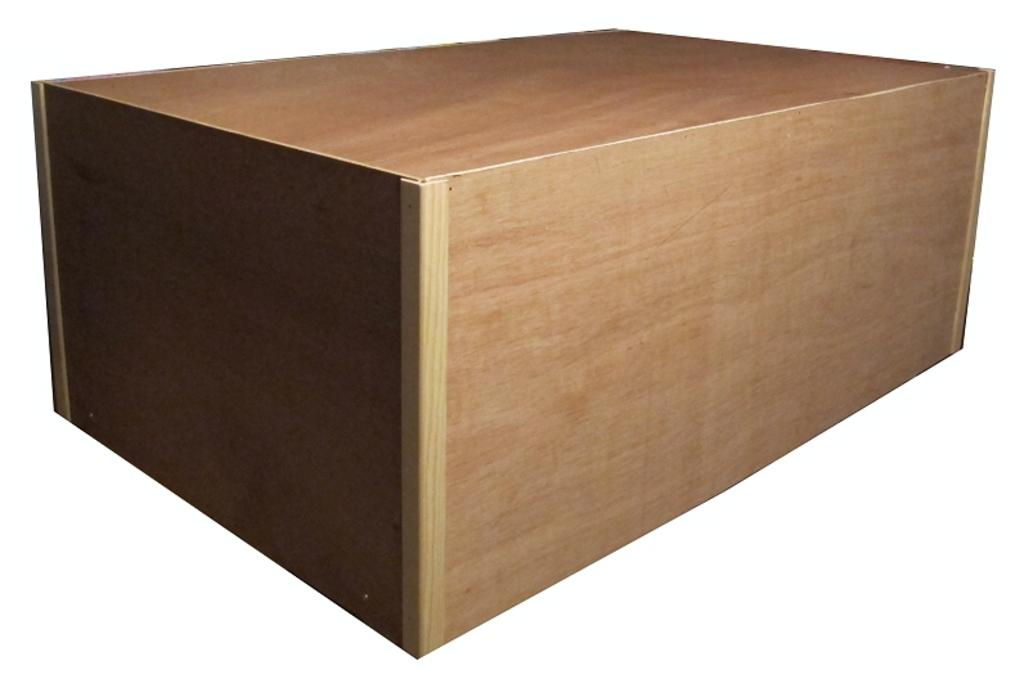What object is the main focus of the image? There is a wooden box in the image. What color is the background of the image? The background of the image is white. What type of battle is depicted in the image? There is no battle present in the image; it features a wooden box against a white background. What organization is responsible for the wooden box in the image? There is no information about any organization being responsible for the wooden box in the image. 